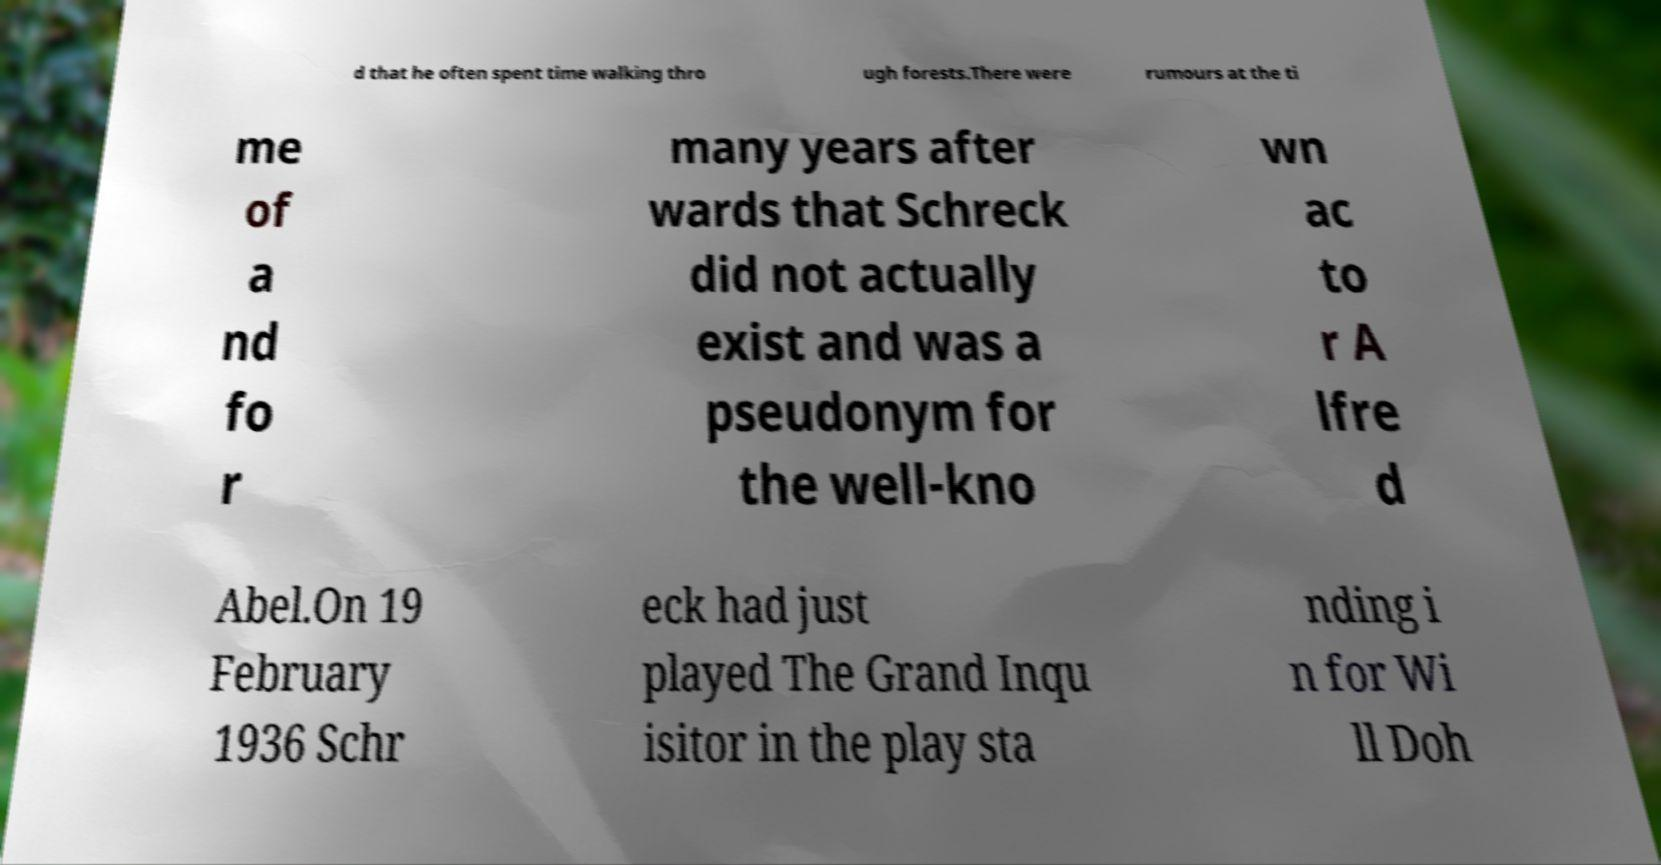There's text embedded in this image that I need extracted. Can you transcribe it verbatim? d that he often spent time walking thro ugh forests.There were rumours at the ti me of a nd fo r many years after wards that Schreck did not actually exist and was a pseudonym for the well-kno wn ac to r A lfre d Abel.On 19 February 1936 Schr eck had just played The Grand Inqu isitor in the play sta nding i n for Wi ll Doh 